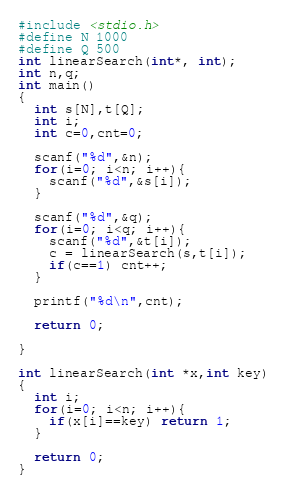Convert code to text. <code><loc_0><loc_0><loc_500><loc_500><_C_>
#include <stdio.h>
#define N 1000
#define Q 500
int linearSearch(int*, int);
int n,q;
int main()
{
  int s[N],t[Q];
  int i;
  int c=0,cnt=0;

  scanf("%d",&n);
  for(i=0; i<n; i++){
    scanf("%d",&s[i]);
  }
  
  scanf("%d",&q);
  for(i=0; i<q; i++){
    scanf("%d",&t[i]);
    c = linearSearch(s,t[i]);
    if(c==1) cnt++;
  }

  printf("%d\n",cnt);

  return 0;
  
}

int linearSearch(int *x,int key)
{
  int i;
  for(i=0; i<n; i++){
    if(x[i]==key) return 1;
  }
  
  return 0;
}</code> 